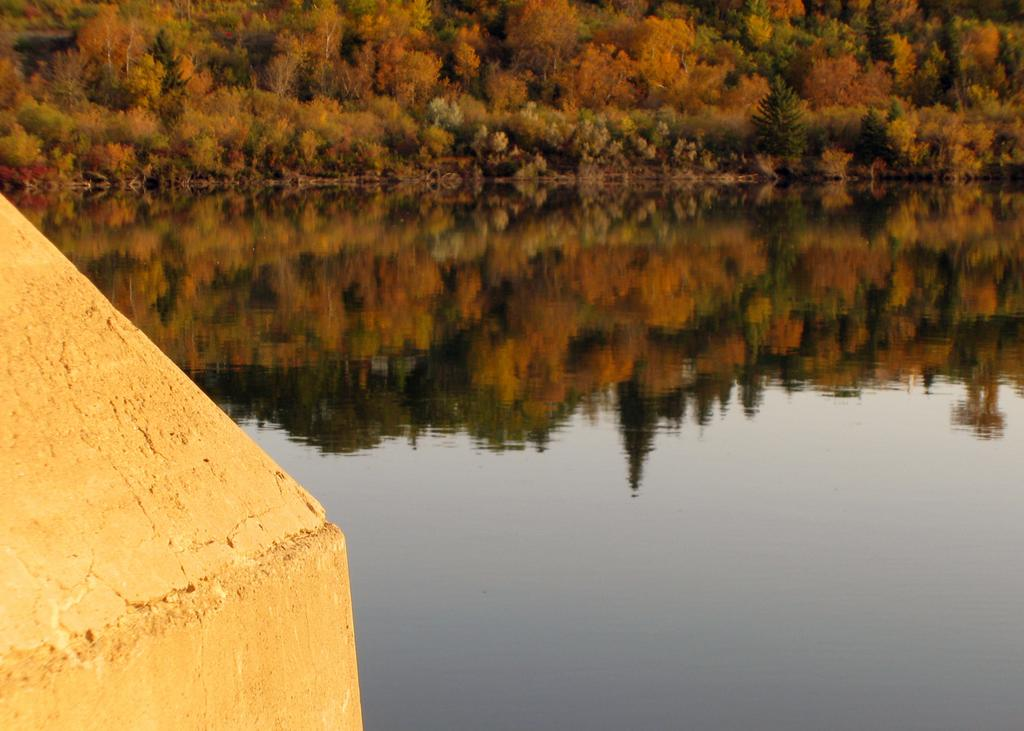What is the primary element present in the image? There is water in the image. What can be seen in the distance in the image? There are trees visible in the background of the image. What is located on the left side of the image? There is a wall on the left side of the image. What type of stocking is hanging from the wall in the image? There is no stocking present in the image. What part of the brain can be seen in the image? There is no brain present in the image. 